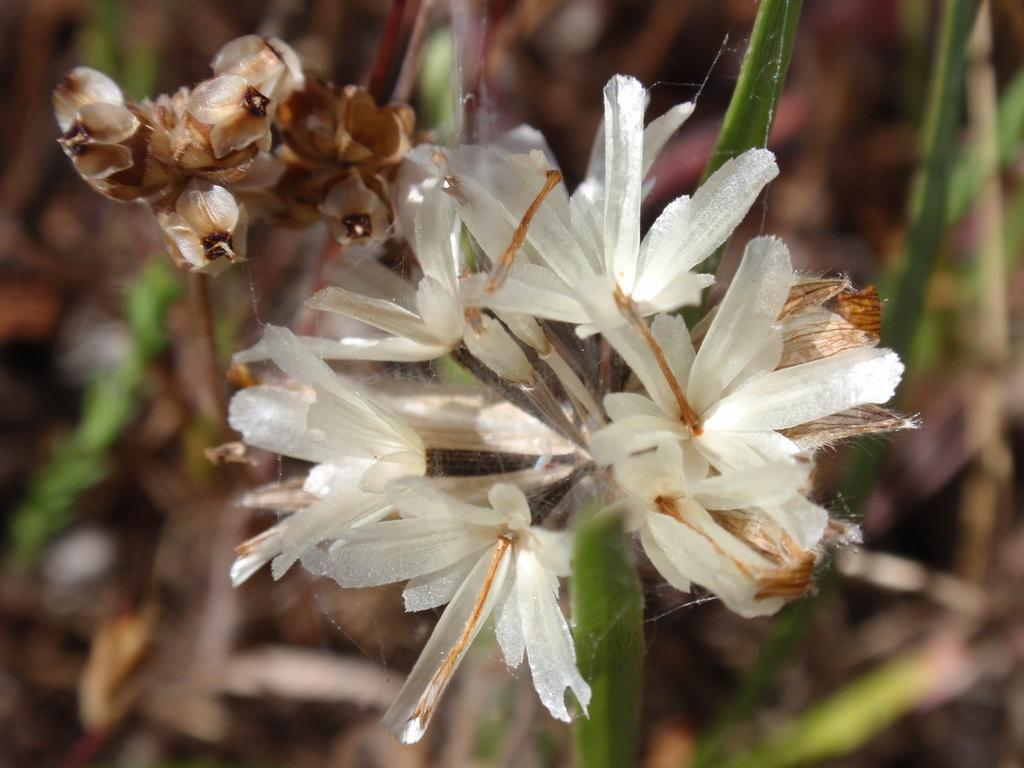What type of plants are in the image? There are flowers in the image. What part of the flowers can be seen in the image? The flowers have leaves. Can you describe the background of the image? The background of the image has a blurred view. What type of sound can be heard coming from the flowers in the image? There is no sound coming from the flowers in the image, as flowers do not produce sound. 